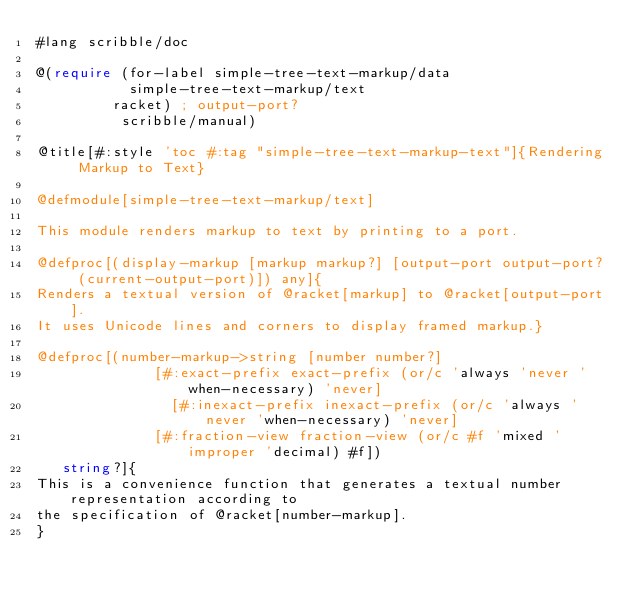<code> <loc_0><loc_0><loc_500><loc_500><_Racket_>#lang scribble/doc

@(require (for-label simple-tree-text-markup/data
	  	     simple-tree-text-markup/text
		     racket) ; output-port?
          scribble/manual)

@title[#:style 'toc #:tag "simple-tree-text-markup-text"]{Rendering Markup to Text}

@defmodule[simple-tree-text-markup/text]

This module renders markup to text by printing to a port.

@defproc[(display-markup [markup markup?] [output-port output-port? (current-output-port)]) any]{
Renders a textual version of @racket[markup] to @racket[output-port].
It uses Unicode lines and corners to display framed markup.}

@defproc[(number-markup->string [number number?]
			        [#:exact-prefix exact-prefix (or/c 'always 'never 'when-necessary) 'never]
	   		        [#:inexact-prefix inexact-prefix (or/c 'always 'never 'when-necessary) 'never]
			        [#:fraction-view fraction-view (or/c #f 'mixed 'improper 'decimal) #f])
	 string?]{
This is a convenience function that generates a textual number representation according to
the specification of @racket[number-markup].
}
</code> 